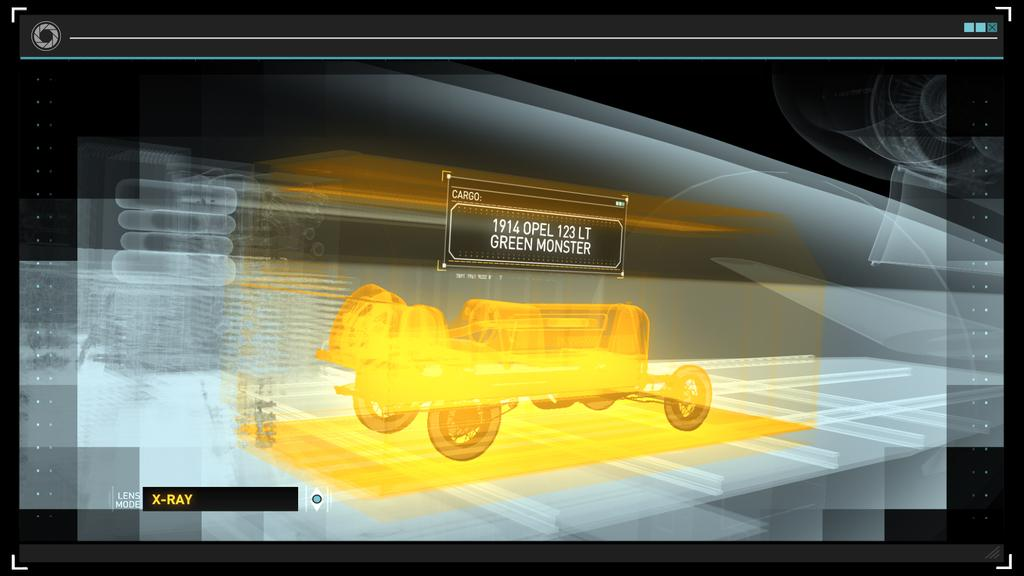What is the main subject of the image? The main subject of the image is an x-ray screen. What can be seen on the x-ray screen? A gold-colored vehicle is visible on the x-ray screen. How is the background of the x-ray screen depicted? The background of the x-ray screen is in gray and black colors. Is there a party happening in the image? There is no indication of a party in the image; it features an x-ray screen with a gold-colored vehicle. Can you tell me how many times the vehicle is being washed in the image? There is no washing activity depicted in the image; it shows an x-ray screen with a gold-colored vehicle. 